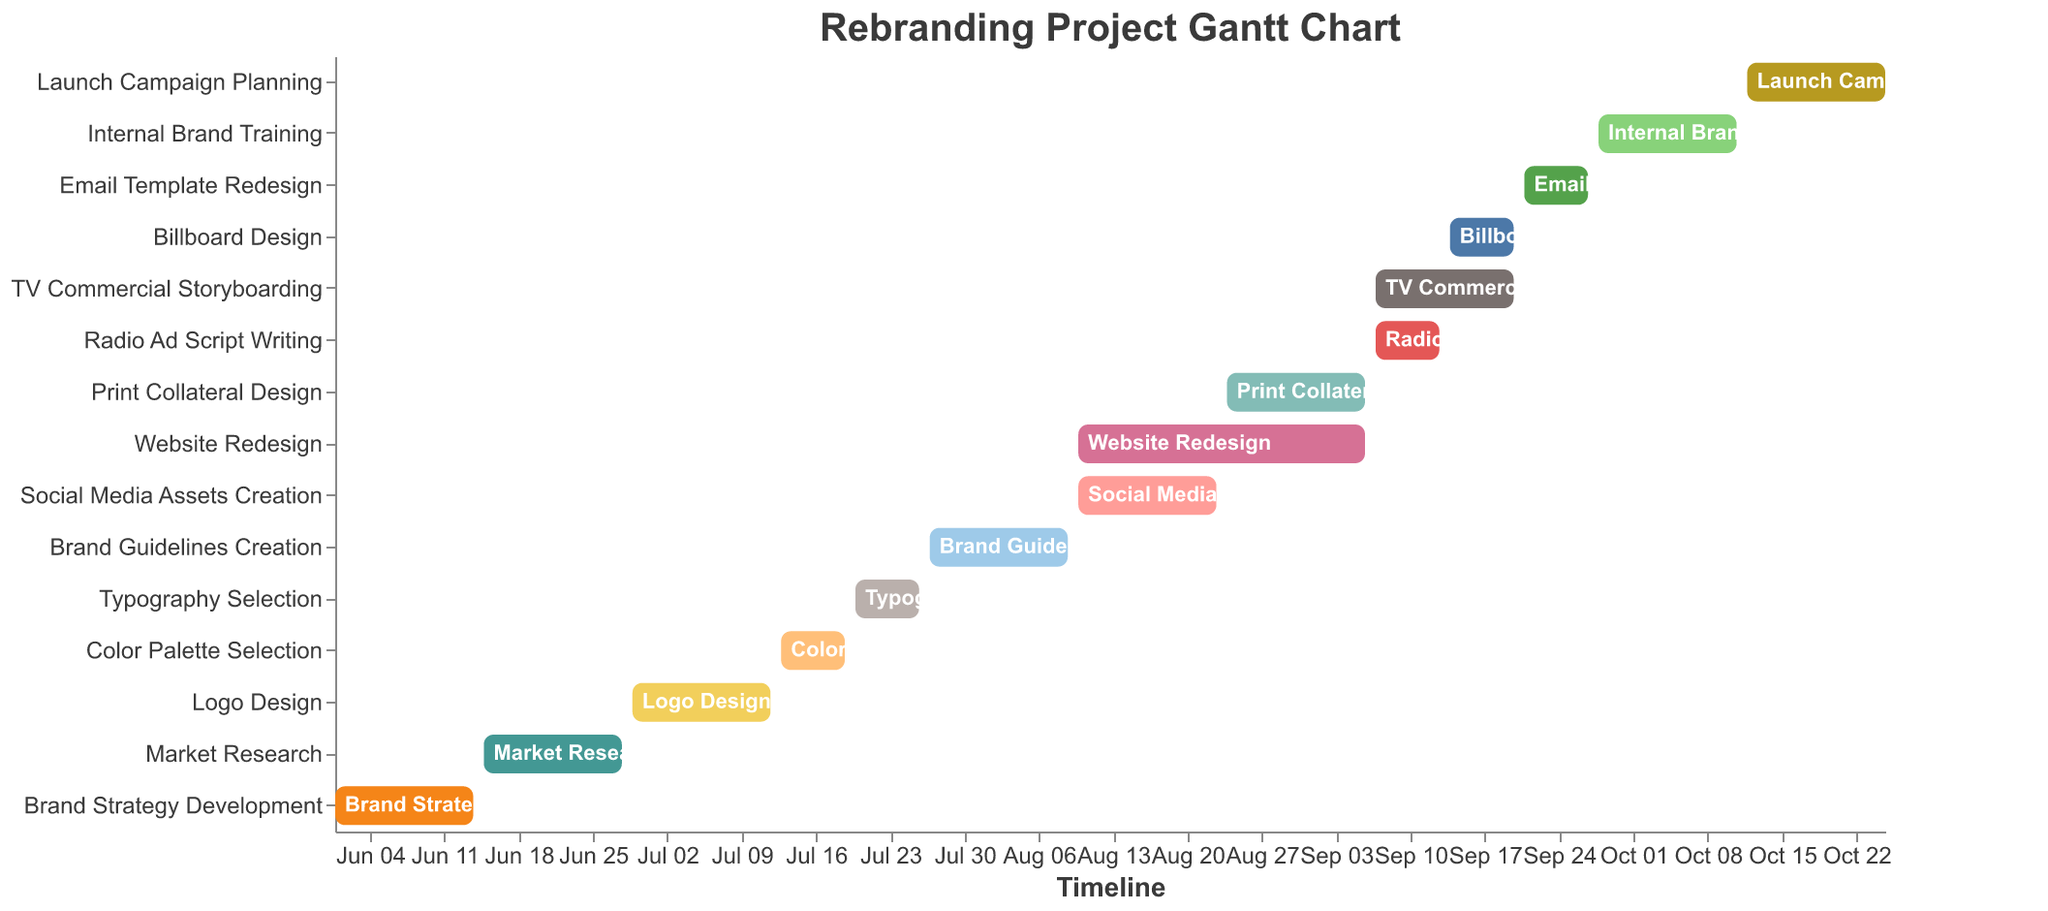What is the title of the Gantt Chart? The title is usually displayed at the top of the chart, indicating the main subject or purpose of the visualization. In this case, the title is "Rebranding Project Gantt Chart".
Answer: Rebranding Project Gantt Chart Which task starts immediately after "Brand Strategy Development"? First, locate the task "Brand Strategy Development" in the Gantt Chart. The task that starts right after it is "Market Research".
Answer: Market Research How many tasks are dependent on "Brand Guidelines Creation"? Locate the "Brand Guidelines Creation" task and observe its dependencies. It shows "Website Redesign", "Social Media Assets Creation", "Print Collateral Design", "TV Commercial Storyboarding", "Radio Ad Script Writing", and "Billboard Design".
Answer: Six What is the duration of the "Website Redesign" task? Identify the start and end dates of the "Website Redesign" task. It starts on "2023-08-10" and ends on "2023-09-06". Calculating the duration involves counting the days between these dates.
Answer: 28 days Which task has the shortest duration and what is that duration? Examine each task's start and end dates to determine their durations. The "Radio Ad Script Writing" task has the shortest duration from "2023-09-07" to "2023-09-13".
Answer: Radio Ad Script Writing, 7 days Which tasks overlap with the "Website Redesign" task? Identify the duration of the "Website Redesign" task and check for other tasks whose timelines intersect with it. These are "Social Media Assets Creation", "Print Collateral Design", and the initial phase of "TV Commercial Storyboarding".
Answer: Social Media Assets Creation, Print Collateral Design, TV Commercial Storyboarding (partially) What is the last task in the project and when does it end? Locate the task that appears last on the Gantt Chart timeline. The "Launch Campaign Planning" task ends on 2023-10-25.
Answer: Launch Campaign Planning, 2023-10-25 Which task directly precedes "Internal Brand Training" and what are its dependencies? Identify the task immediately before "Internal Brand Training". It is "Email Template Redesign", which depends on "Website Redesign".
Answer: Email Template Redesign, Website Redesign Which tasks have dependencies on multiple preceding tasks? Look for tasks in the Gantt Chart that list more than one dependency. "Brand Guidelines Creation" has dependencies on "Logo Design", "Color Palette Selection", and "Typography Selection".
Answer: Brand Guidelines Creation 